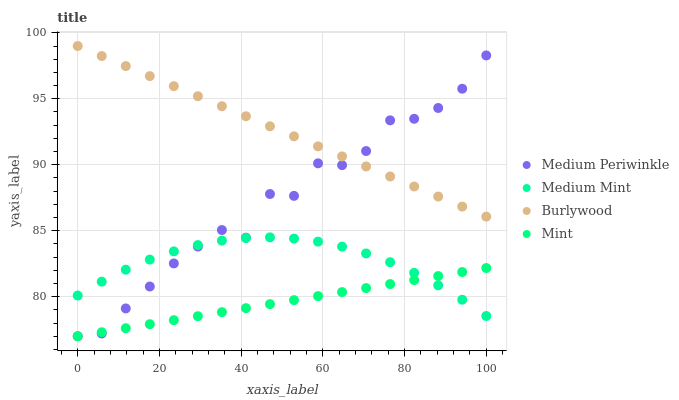Does Mint have the minimum area under the curve?
Answer yes or no. Yes. Does Burlywood have the maximum area under the curve?
Answer yes or no. Yes. Does Medium Periwinkle have the minimum area under the curve?
Answer yes or no. No. Does Medium Periwinkle have the maximum area under the curve?
Answer yes or no. No. Is Mint the smoothest?
Answer yes or no. Yes. Is Medium Periwinkle the roughest?
Answer yes or no. Yes. Is Burlywood the smoothest?
Answer yes or no. No. Is Burlywood the roughest?
Answer yes or no. No. Does Medium Periwinkle have the lowest value?
Answer yes or no. Yes. Does Burlywood have the lowest value?
Answer yes or no. No. Does Burlywood have the highest value?
Answer yes or no. Yes. Does Medium Periwinkle have the highest value?
Answer yes or no. No. Is Mint less than Burlywood?
Answer yes or no. Yes. Is Burlywood greater than Medium Mint?
Answer yes or no. Yes. Does Medium Periwinkle intersect Medium Mint?
Answer yes or no. Yes. Is Medium Periwinkle less than Medium Mint?
Answer yes or no. No. Is Medium Periwinkle greater than Medium Mint?
Answer yes or no. No. Does Mint intersect Burlywood?
Answer yes or no. No. 